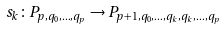Convert formula to latex. <formula><loc_0><loc_0><loc_500><loc_500>s _ { k } \colon P _ { p , q _ { 0 } , \dots , q _ { p } } \to { P _ { p + 1 , q _ { 0 } , \dots , q _ { k } , q _ { k } , \dots , q _ { p } } }</formula> 